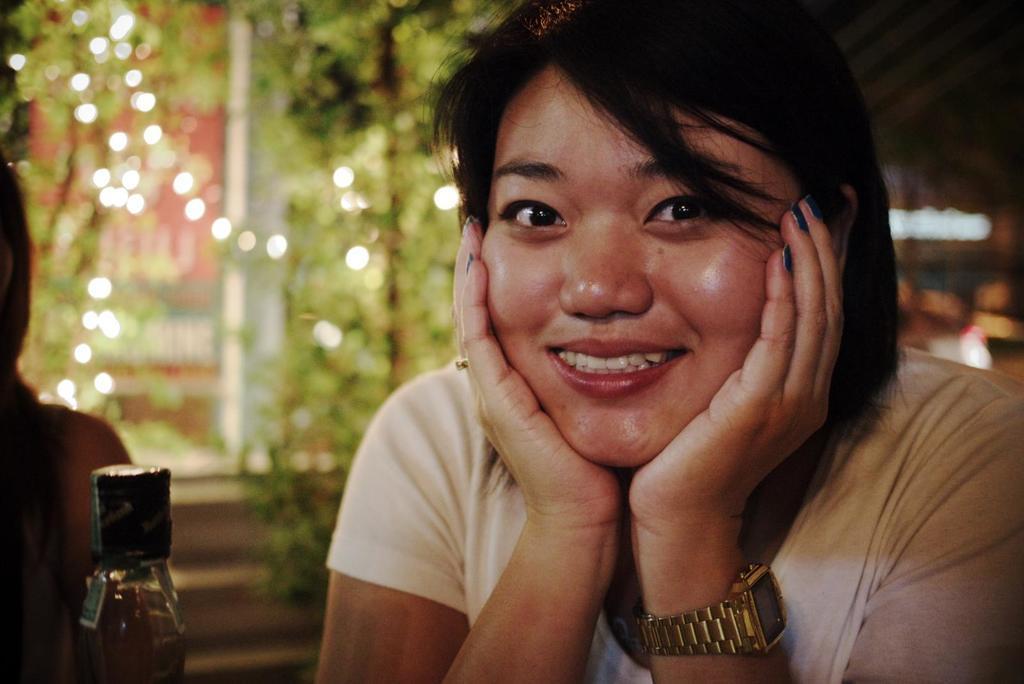Describe this image in one or two sentences. A woman is there in this picture smiling. She is wearing a watch. There is a person at the left side of the image and bottle at the bottom of image. Background there are few plants. 